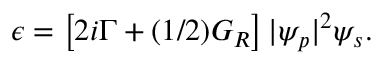Convert formula to latex. <formula><loc_0><loc_0><loc_500><loc_500>\begin{array} { r } { \epsilon = \left [ 2 i \Gamma + ( 1 / 2 ) G _ { R } \right ] | \psi _ { p } | ^ { 2 } \psi _ { s } . } \end{array}</formula> 